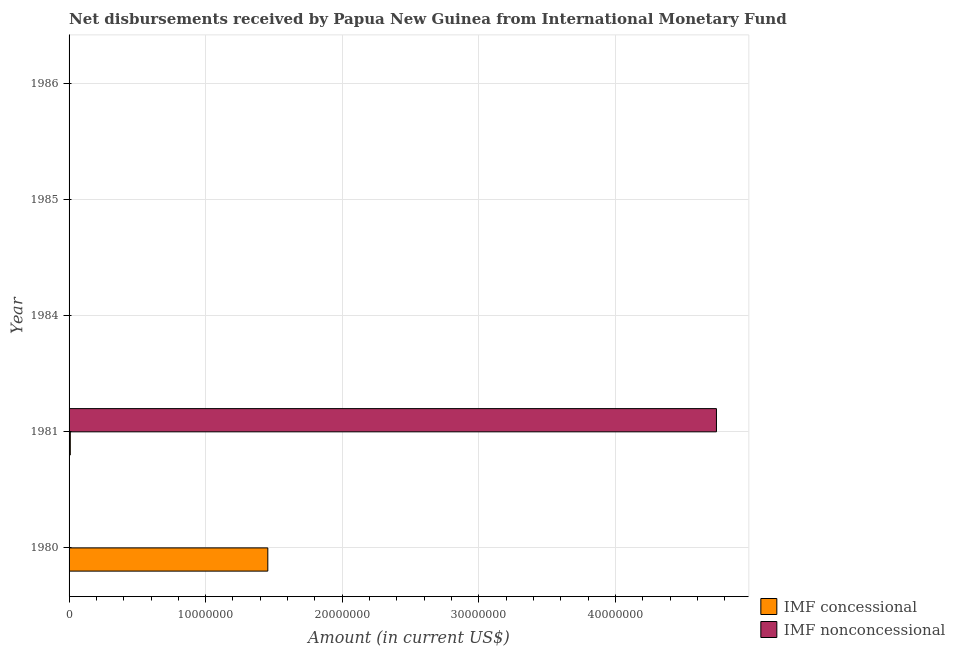How many different coloured bars are there?
Your answer should be compact. 2. What is the net concessional disbursements from imf in 1980?
Make the answer very short. 1.46e+07. Across all years, what is the maximum net concessional disbursements from imf?
Provide a short and direct response. 1.46e+07. In which year was the net non concessional disbursements from imf maximum?
Offer a very short reply. 1981. What is the total net concessional disbursements from imf in the graph?
Give a very brief answer. 1.46e+07. What is the difference between the net concessional disbursements from imf in 1980 and that in 1981?
Give a very brief answer. 1.45e+07. What is the difference between the net non concessional disbursements from imf in 1984 and the net concessional disbursements from imf in 1985?
Your answer should be very brief. 0. What is the average net concessional disbursements from imf per year?
Offer a very short reply. 2.93e+06. In the year 1981, what is the difference between the net concessional disbursements from imf and net non concessional disbursements from imf?
Your response must be concise. -4.73e+07. What is the difference between the highest and the lowest net concessional disbursements from imf?
Offer a terse response. 1.46e+07. How many years are there in the graph?
Give a very brief answer. 5. What is the difference between two consecutive major ticks on the X-axis?
Your response must be concise. 1.00e+07. Are the values on the major ticks of X-axis written in scientific E-notation?
Your response must be concise. No. Does the graph contain grids?
Make the answer very short. Yes. How many legend labels are there?
Ensure brevity in your answer.  2. What is the title of the graph?
Offer a terse response. Net disbursements received by Papua New Guinea from International Monetary Fund. What is the label or title of the X-axis?
Make the answer very short. Amount (in current US$). What is the label or title of the Y-axis?
Make the answer very short. Year. What is the Amount (in current US$) of IMF concessional in 1980?
Keep it short and to the point. 1.46e+07. What is the Amount (in current US$) in IMF concessional in 1981?
Keep it short and to the point. 9.00e+04. What is the Amount (in current US$) in IMF nonconcessional in 1981?
Ensure brevity in your answer.  4.74e+07. What is the Amount (in current US$) of IMF concessional in 1984?
Keep it short and to the point. 0. What is the Amount (in current US$) in IMF nonconcessional in 1985?
Provide a succinct answer. 0. What is the Amount (in current US$) in IMF concessional in 1986?
Your answer should be very brief. 0. What is the Amount (in current US$) in IMF nonconcessional in 1986?
Provide a short and direct response. 0. Across all years, what is the maximum Amount (in current US$) of IMF concessional?
Your answer should be very brief. 1.46e+07. Across all years, what is the maximum Amount (in current US$) of IMF nonconcessional?
Ensure brevity in your answer.  4.74e+07. Across all years, what is the minimum Amount (in current US$) in IMF concessional?
Provide a succinct answer. 0. What is the total Amount (in current US$) of IMF concessional in the graph?
Your answer should be compact. 1.46e+07. What is the total Amount (in current US$) of IMF nonconcessional in the graph?
Offer a terse response. 4.74e+07. What is the difference between the Amount (in current US$) in IMF concessional in 1980 and that in 1981?
Your answer should be very brief. 1.45e+07. What is the difference between the Amount (in current US$) in IMF concessional in 1980 and the Amount (in current US$) in IMF nonconcessional in 1981?
Your answer should be very brief. -3.28e+07. What is the average Amount (in current US$) in IMF concessional per year?
Provide a short and direct response. 2.93e+06. What is the average Amount (in current US$) of IMF nonconcessional per year?
Your answer should be compact. 9.48e+06. In the year 1981, what is the difference between the Amount (in current US$) in IMF concessional and Amount (in current US$) in IMF nonconcessional?
Offer a terse response. -4.73e+07. What is the ratio of the Amount (in current US$) in IMF concessional in 1980 to that in 1981?
Make the answer very short. 161.69. What is the difference between the highest and the lowest Amount (in current US$) in IMF concessional?
Keep it short and to the point. 1.46e+07. What is the difference between the highest and the lowest Amount (in current US$) of IMF nonconcessional?
Offer a very short reply. 4.74e+07. 